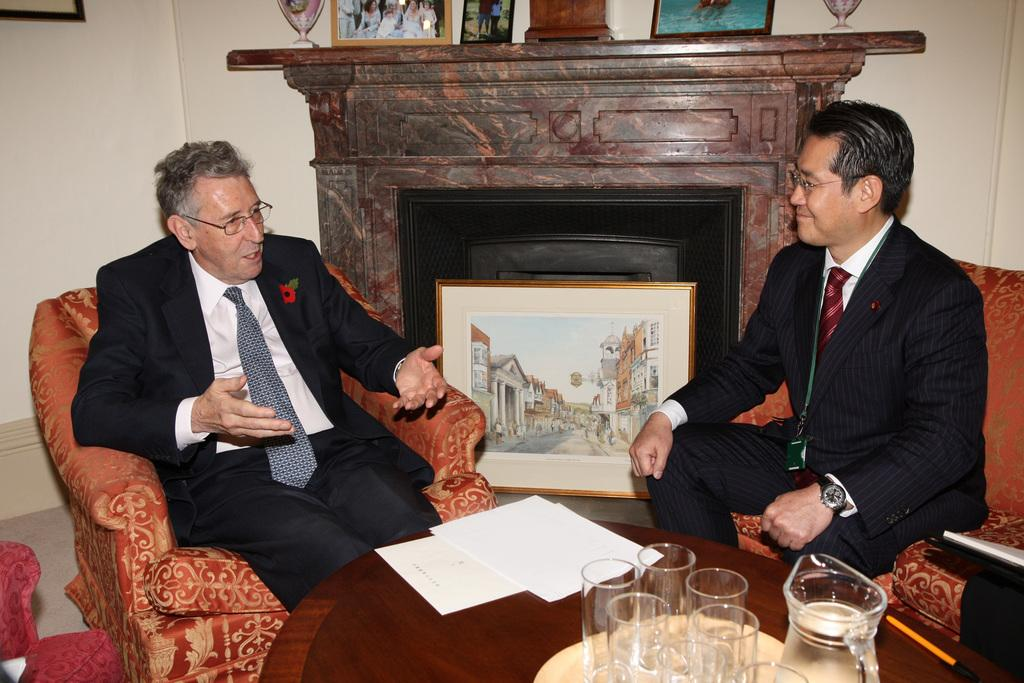How many people are in the image? There are two men in the image. What are the men doing in the image? The men are sitting on chairs. Where are the chairs located in relation to the table? The chairs are in front of a table. What can be seen on the table in the image? There are glasses and other objects on the table. What type of magic trick is the man on the left performing in the image? There is no magic trick being performed in the image; the men are simply sitting on chairs. 